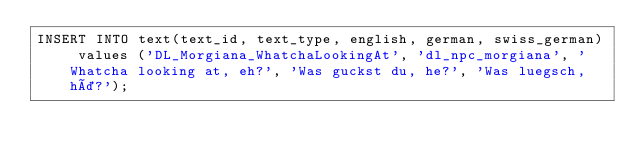Convert code to text. <code><loc_0><loc_0><loc_500><loc_500><_SQL_>INSERT INTO text(text_id, text_type, english, german, swiss_german) values ('DL_Morgiana_WhatchaLookingAt', 'dl_npc_morgiana', 'Whatcha looking at, eh?', 'Was guckst du, he?', 'Was luegsch, hä?');
</code> 